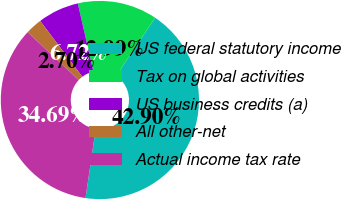<chart> <loc_0><loc_0><loc_500><loc_500><pie_chart><fcel>US federal statutory income<fcel>Tax on global activities<fcel>US business credits (a)<fcel>All other-net<fcel>Actual income tax rate<nl><fcel>42.9%<fcel>12.99%<fcel>6.72%<fcel>2.7%<fcel>34.69%<nl></chart> 